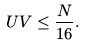Convert formula to latex. <formula><loc_0><loc_0><loc_500><loc_500>U V \leq \frac { N } { 1 6 } .</formula> 